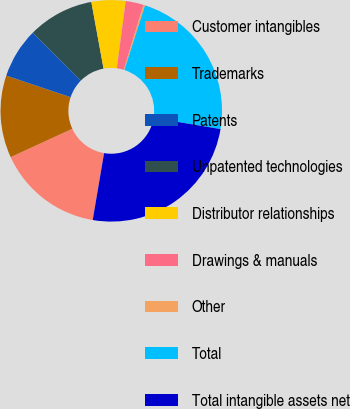Convert chart to OTSL. <chart><loc_0><loc_0><loc_500><loc_500><pie_chart><fcel>Customer intangibles<fcel>Trademarks<fcel>Patents<fcel>Unpatented technologies<fcel>Distributor relationships<fcel>Drawings & manuals<fcel>Other<fcel>Total<fcel>Total intangible assets net<nl><fcel>15.46%<fcel>12.01%<fcel>7.31%<fcel>9.66%<fcel>4.96%<fcel>2.61%<fcel>0.25%<fcel>22.7%<fcel>25.05%<nl></chart> 